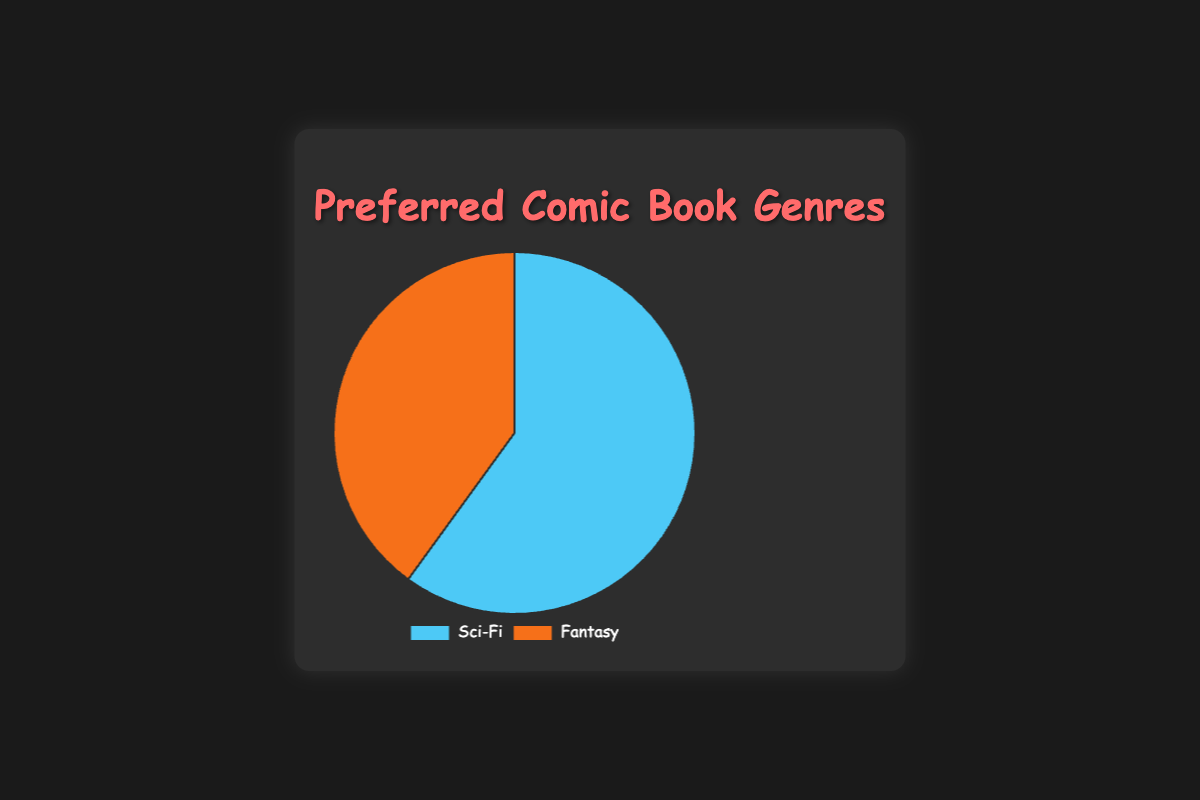What percentage of people prefer Sci-Fi over Fantasy? The pie chart shows that 60% prefer Sci-Fi and 40% prefer Fantasy. So, the percentage of people who prefer Sci-Fi over Fantasy is 60% - 40% = 20%.
Answer: 20% Which genre is preferred more, Sci-Fi or Fantasy? The pie chart shows that Sci-Fi is preferred by 60% of people, while Fantasy is preferred by 40%. 60% is greater than 40%, so Sci-Fi is preferred more.
Answer: Sci-Fi How much larger is the slice representing Sci-Fi compared to the slice representing Fantasy? Sci-Fi is represented by 60% and Fantasy by 40%. The difference is 60% - 40% = 20%.
Answer: 20% What is the ratio of people who prefer Sci-Fi to those who prefer Fantasy? The percentages are 60% for Sci-Fi and 40% for Fantasy. The ratio is 60:40 which can be simplified to 3:2.
Answer: 3:2 If the total number of respondents is 100, how many prefer each genre? 60% of 100 respondents prefer Sci-Fi and 40% prefer Fantasy. This equates to 60 respondents for Sci-Fi and 40 for Fantasy.
Answer: 60 for Sci-Fi, 40 for Fantasy What fraction of the pie chart does the Sci-Fi genre cover? Sci-Fi covers 60% of the pie chart. As a fraction, this is 60/100 or 3/5.
Answer: 3/5 By what factor is the population that prefers Sci-Fi greater than the population that prefers Fantasy? The population that prefers Sci-Fi is 60% and Fantasy is 40%. The factor is 60% / 40% = 1.5.
Answer: 1.5 What percentage of respondents prefer genres other than Sci-Fi or Fantasy? The only mentioned genres are Sci-Fi (60%) and Fantasy (40%), making up a total of 100%. So, the percentage preferring other genres is 0%.
Answer: 0% If you were to highlight the genre with the larger preference, which one would it be, and what color would you use? The genre with the larger preference is Sci-Fi, and according to the chart's key, Sci-Fi is represented with a blue color
Answer: Sci-Fi, blue How do the segment sizes for Sci-Fi and Fantasy compare visually? The Sci-Fi segment is larger and takes up more space on the pie chart compared to the Fantasy segment. The larger segment indicates the higher preference visually.
Answer: Sci-Fi segment is larger 